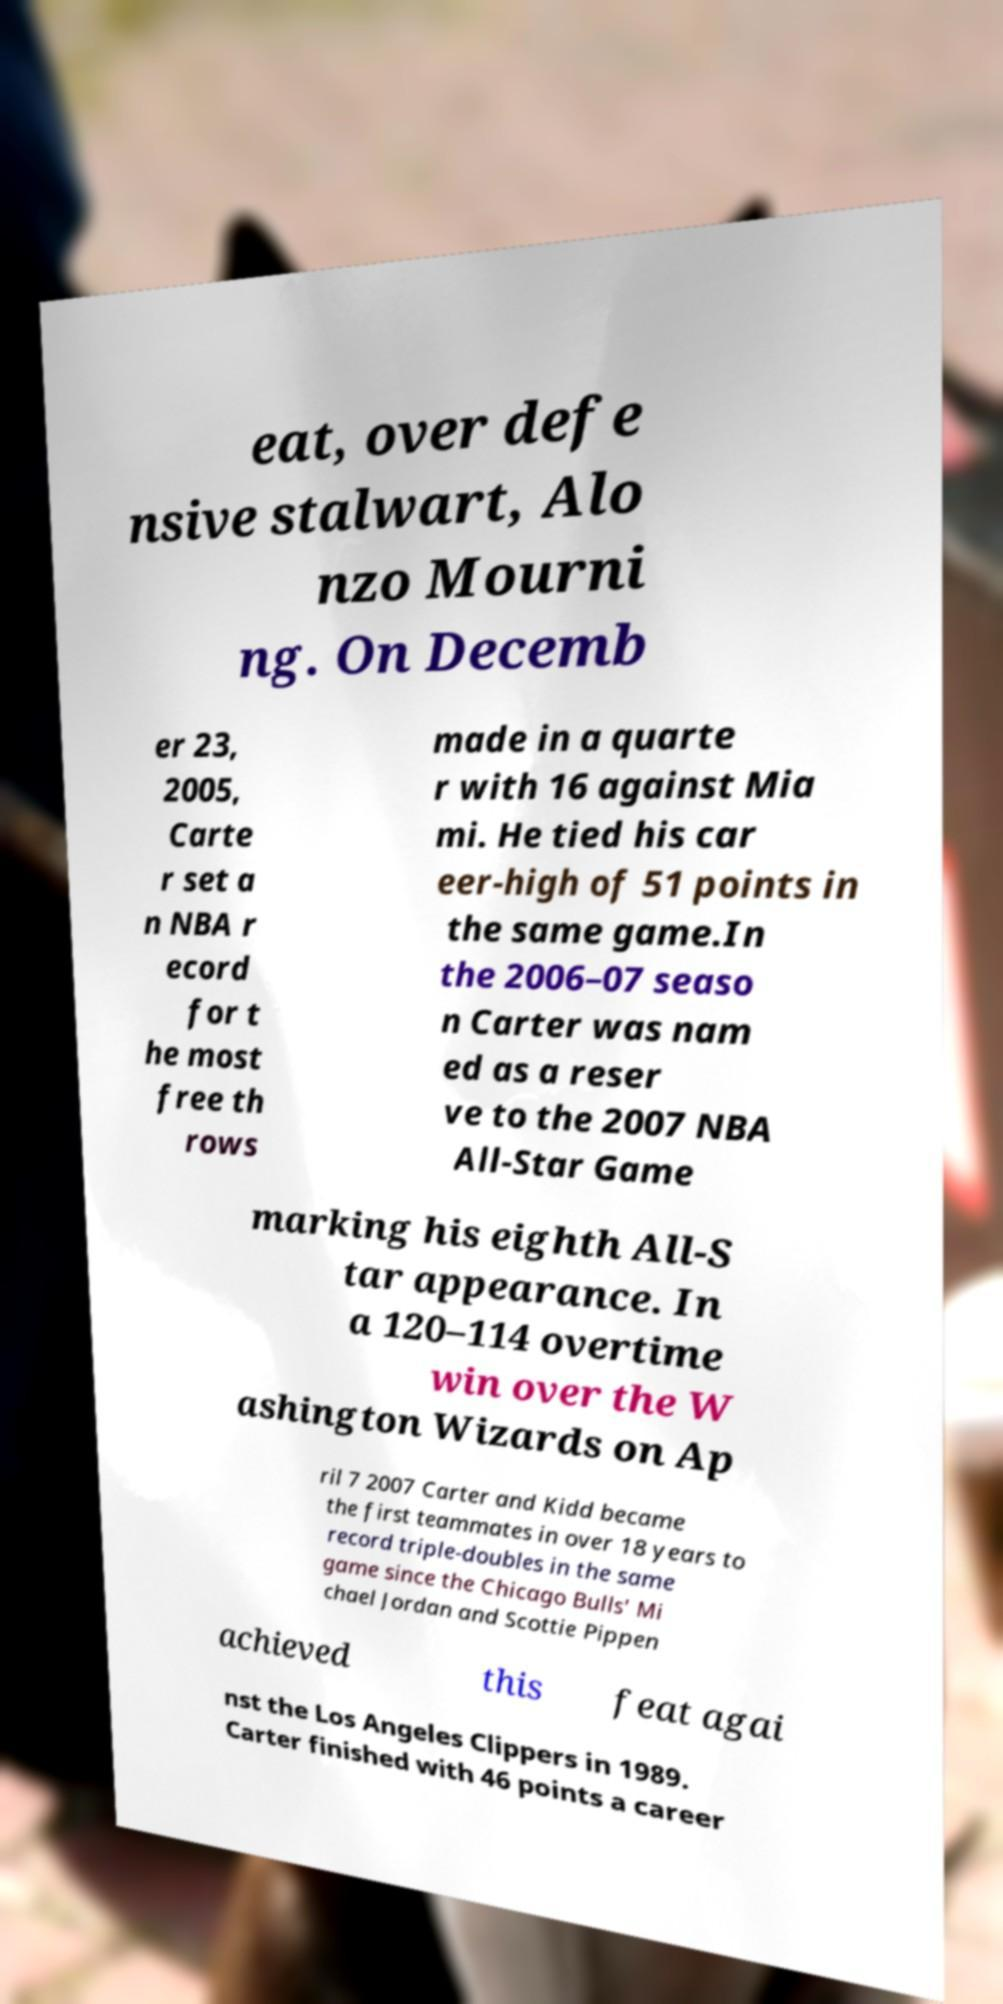Can you accurately transcribe the text from the provided image for me? eat, over defe nsive stalwart, Alo nzo Mourni ng. On Decemb er 23, 2005, Carte r set a n NBA r ecord for t he most free th rows made in a quarte r with 16 against Mia mi. He tied his car eer-high of 51 points in the same game.In the 2006–07 seaso n Carter was nam ed as a reser ve to the 2007 NBA All-Star Game marking his eighth All-S tar appearance. In a 120–114 overtime win over the W ashington Wizards on Ap ril 7 2007 Carter and Kidd became the first teammates in over 18 years to record triple-doubles in the same game since the Chicago Bulls' Mi chael Jordan and Scottie Pippen achieved this feat agai nst the Los Angeles Clippers in 1989. Carter finished with 46 points a career 